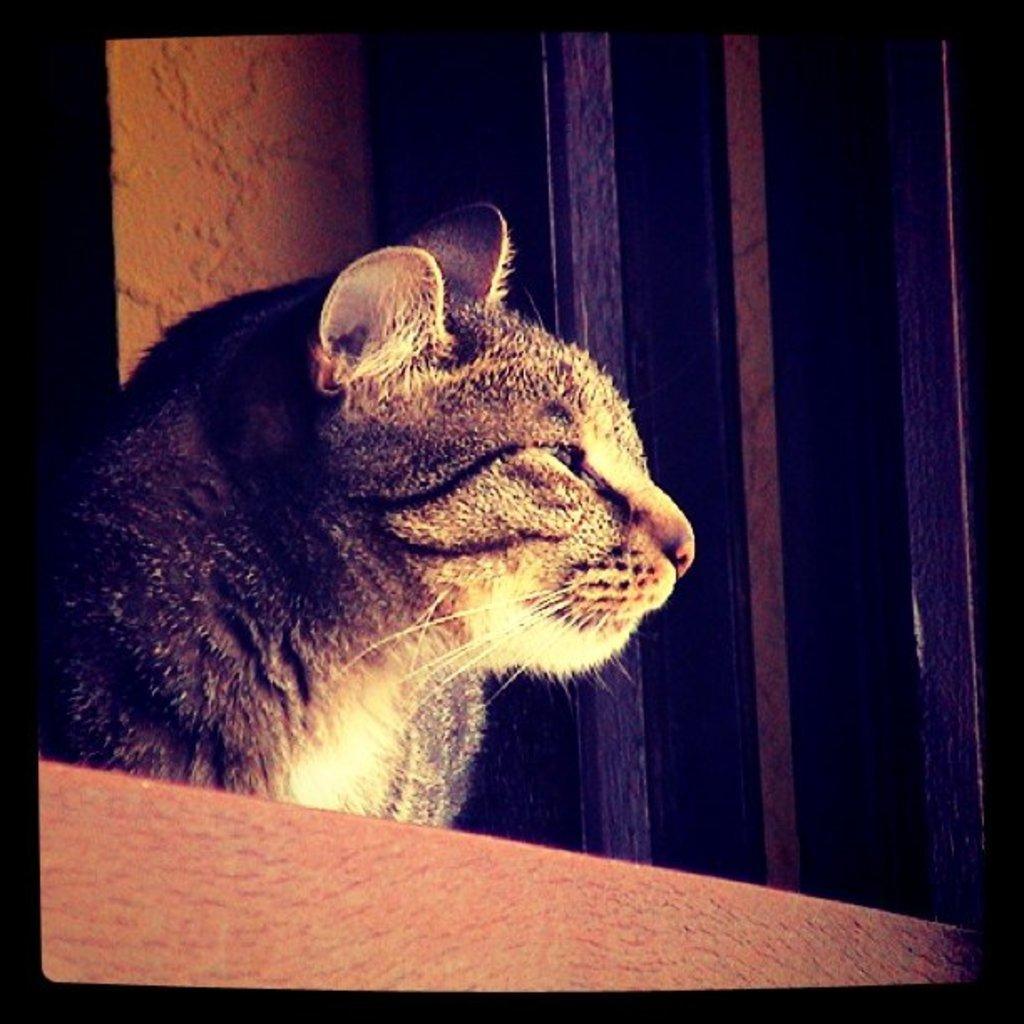Describe this image in one or two sentences. There is a cat in the foreground area of the image, it seems like a window in the background. 